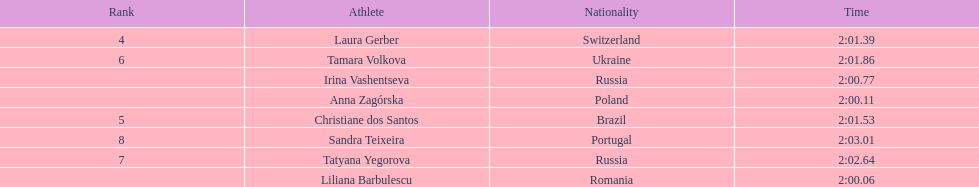Anna zagorska recieved 2nd place, what was her time? 2:00.11. 